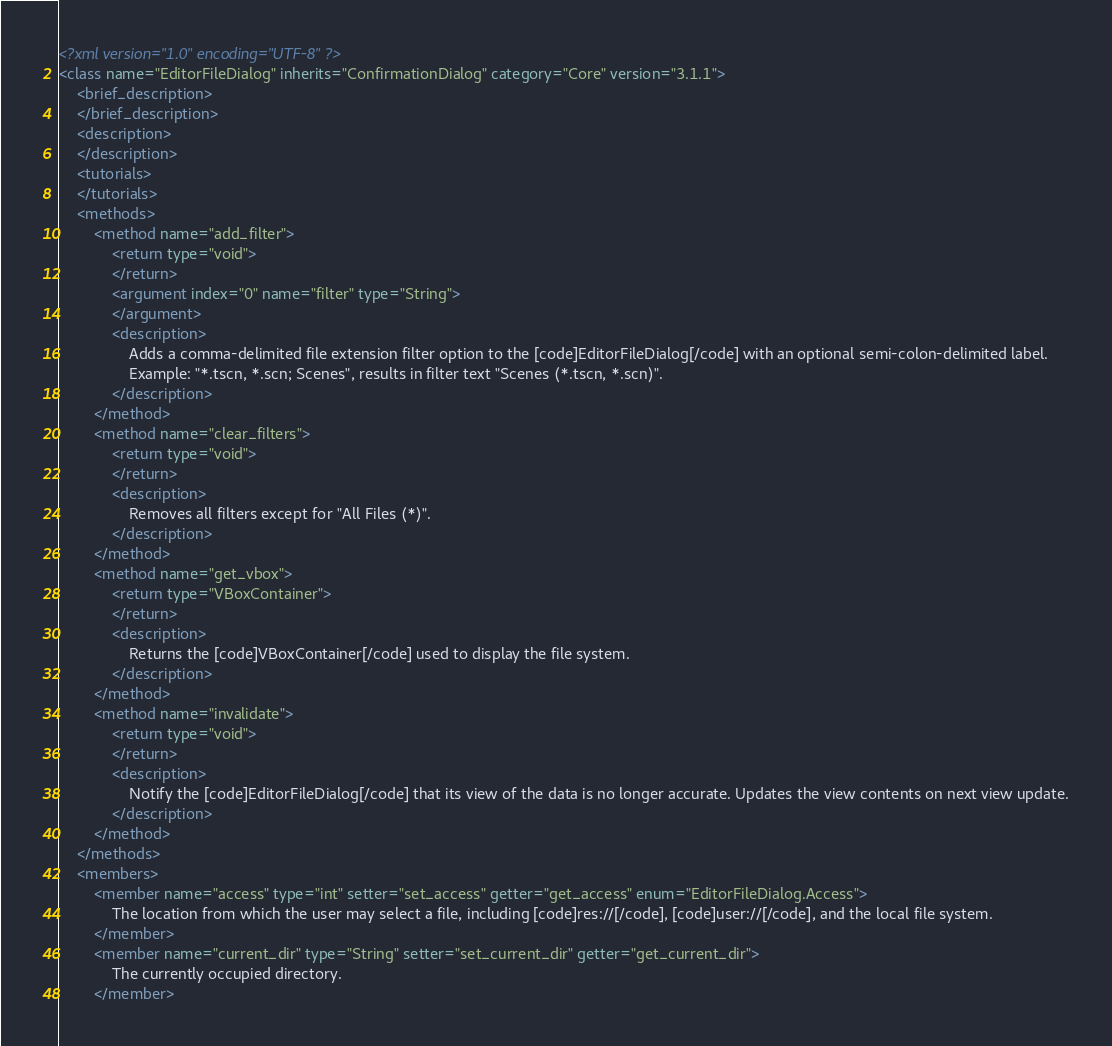<code> <loc_0><loc_0><loc_500><loc_500><_XML_><?xml version="1.0" encoding="UTF-8" ?>
<class name="EditorFileDialog" inherits="ConfirmationDialog" category="Core" version="3.1.1">
	<brief_description>
	</brief_description>
	<description>
	</description>
	<tutorials>
	</tutorials>
	<methods>
		<method name="add_filter">
			<return type="void">
			</return>
			<argument index="0" name="filter" type="String">
			</argument>
			<description>
				Adds a comma-delimited file extension filter option to the [code]EditorFileDialog[/code] with an optional semi-colon-delimited label.
				Example: "*.tscn, *.scn; Scenes", results in filter text "Scenes (*.tscn, *.scn)".
			</description>
		</method>
		<method name="clear_filters">
			<return type="void">
			</return>
			<description>
				Removes all filters except for "All Files (*)".
			</description>
		</method>
		<method name="get_vbox">
			<return type="VBoxContainer">
			</return>
			<description>
				Returns the [code]VBoxContainer[/code] used to display the file system.
			</description>
		</method>
		<method name="invalidate">
			<return type="void">
			</return>
			<description>
				Notify the [code]EditorFileDialog[/code] that its view of the data is no longer accurate. Updates the view contents on next view update.
			</description>
		</method>
	</methods>
	<members>
		<member name="access" type="int" setter="set_access" getter="get_access" enum="EditorFileDialog.Access">
			The location from which the user may select a file, including [code]res://[/code], [code]user://[/code], and the local file system.
		</member>
		<member name="current_dir" type="String" setter="set_current_dir" getter="get_current_dir">
			The currently occupied directory.
		</member></code> 